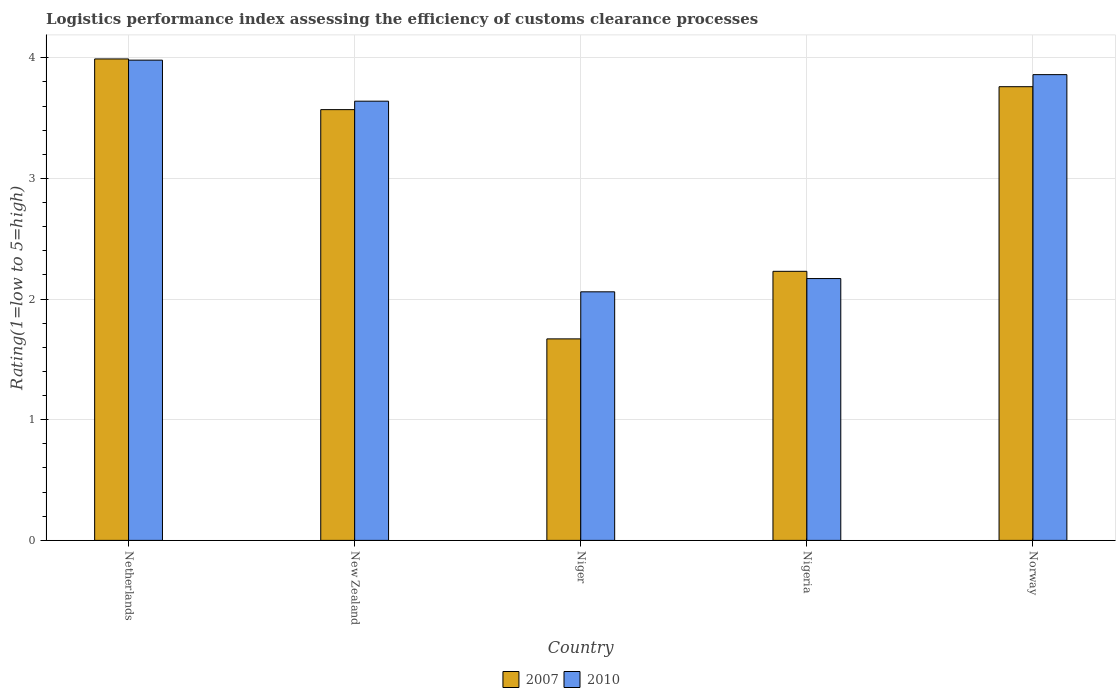How many different coloured bars are there?
Make the answer very short. 2. How many groups of bars are there?
Your answer should be compact. 5. Are the number of bars on each tick of the X-axis equal?
Your answer should be very brief. Yes. What is the label of the 5th group of bars from the left?
Your answer should be compact. Norway. In how many cases, is the number of bars for a given country not equal to the number of legend labels?
Ensure brevity in your answer.  0. What is the Logistic performance index in 2010 in Nigeria?
Your answer should be very brief. 2.17. Across all countries, what is the maximum Logistic performance index in 2010?
Ensure brevity in your answer.  3.98. Across all countries, what is the minimum Logistic performance index in 2010?
Ensure brevity in your answer.  2.06. In which country was the Logistic performance index in 2010 minimum?
Your answer should be very brief. Niger. What is the total Logistic performance index in 2010 in the graph?
Provide a succinct answer. 15.71. What is the difference between the Logistic performance index in 2007 in New Zealand and that in Niger?
Keep it short and to the point. 1.9. What is the difference between the Logistic performance index in 2007 in Niger and the Logistic performance index in 2010 in New Zealand?
Offer a terse response. -1.97. What is the average Logistic performance index in 2007 per country?
Make the answer very short. 3.04. What is the difference between the Logistic performance index of/in 2007 and Logistic performance index of/in 2010 in New Zealand?
Ensure brevity in your answer.  -0.07. In how many countries, is the Logistic performance index in 2007 greater than 3.8?
Your answer should be very brief. 1. What is the ratio of the Logistic performance index in 2010 in Netherlands to that in New Zealand?
Your response must be concise. 1.09. Is the Logistic performance index in 2010 in Netherlands less than that in Norway?
Offer a very short reply. No. Is the difference between the Logistic performance index in 2007 in New Zealand and Niger greater than the difference between the Logistic performance index in 2010 in New Zealand and Niger?
Your answer should be compact. Yes. What is the difference between the highest and the second highest Logistic performance index in 2010?
Ensure brevity in your answer.  0.22. What is the difference between the highest and the lowest Logistic performance index in 2007?
Your response must be concise. 2.32. Is the sum of the Logistic performance index in 2007 in Netherlands and Nigeria greater than the maximum Logistic performance index in 2010 across all countries?
Provide a succinct answer. Yes. Are all the bars in the graph horizontal?
Your answer should be very brief. No. Are the values on the major ticks of Y-axis written in scientific E-notation?
Your answer should be very brief. No. Does the graph contain any zero values?
Offer a terse response. No. How many legend labels are there?
Provide a short and direct response. 2. What is the title of the graph?
Your answer should be compact. Logistics performance index assessing the efficiency of customs clearance processes. What is the label or title of the Y-axis?
Your answer should be compact. Rating(1=low to 5=high). What is the Rating(1=low to 5=high) of 2007 in Netherlands?
Provide a short and direct response. 3.99. What is the Rating(1=low to 5=high) in 2010 in Netherlands?
Offer a very short reply. 3.98. What is the Rating(1=low to 5=high) of 2007 in New Zealand?
Offer a terse response. 3.57. What is the Rating(1=low to 5=high) of 2010 in New Zealand?
Your answer should be compact. 3.64. What is the Rating(1=low to 5=high) of 2007 in Niger?
Make the answer very short. 1.67. What is the Rating(1=low to 5=high) of 2010 in Niger?
Provide a short and direct response. 2.06. What is the Rating(1=low to 5=high) of 2007 in Nigeria?
Ensure brevity in your answer.  2.23. What is the Rating(1=low to 5=high) of 2010 in Nigeria?
Provide a short and direct response. 2.17. What is the Rating(1=low to 5=high) in 2007 in Norway?
Offer a terse response. 3.76. What is the Rating(1=low to 5=high) in 2010 in Norway?
Make the answer very short. 3.86. Across all countries, what is the maximum Rating(1=low to 5=high) of 2007?
Keep it short and to the point. 3.99. Across all countries, what is the maximum Rating(1=low to 5=high) of 2010?
Your answer should be compact. 3.98. Across all countries, what is the minimum Rating(1=low to 5=high) in 2007?
Your response must be concise. 1.67. Across all countries, what is the minimum Rating(1=low to 5=high) in 2010?
Offer a terse response. 2.06. What is the total Rating(1=low to 5=high) of 2007 in the graph?
Your answer should be compact. 15.22. What is the total Rating(1=low to 5=high) of 2010 in the graph?
Offer a terse response. 15.71. What is the difference between the Rating(1=low to 5=high) in 2007 in Netherlands and that in New Zealand?
Your answer should be very brief. 0.42. What is the difference between the Rating(1=low to 5=high) in 2010 in Netherlands and that in New Zealand?
Give a very brief answer. 0.34. What is the difference between the Rating(1=low to 5=high) in 2007 in Netherlands and that in Niger?
Your answer should be compact. 2.32. What is the difference between the Rating(1=low to 5=high) in 2010 in Netherlands and that in Niger?
Make the answer very short. 1.92. What is the difference between the Rating(1=low to 5=high) of 2007 in Netherlands and that in Nigeria?
Your response must be concise. 1.76. What is the difference between the Rating(1=low to 5=high) of 2010 in Netherlands and that in Nigeria?
Ensure brevity in your answer.  1.81. What is the difference between the Rating(1=low to 5=high) of 2007 in Netherlands and that in Norway?
Offer a terse response. 0.23. What is the difference between the Rating(1=low to 5=high) of 2010 in Netherlands and that in Norway?
Your answer should be compact. 0.12. What is the difference between the Rating(1=low to 5=high) of 2010 in New Zealand and that in Niger?
Give a very brief answer. 1.58. What is the difference between the Rating(1=low to 5=high) of 2007 in New Zealand and that in Nigeria?
Your answer should be compact. 1.34. What is the difference between the Rating(1=low to 5=high) of 2010 in New Zealand and that in Nigeria?
Make the answer very short. 1.47. What is the difference between the Rating(1=low to 5=high) in 2007 in New Zealand and that in Norway?
Provide a succinct answer. -0.19. What is the difference between the Rating(1=low to 5=high) in 2010 in New Zealand and that in Norway?
Your answer should be very brief. -0.22. What is the difference between the Rating(1=low to 5=high) in 2007 in Niger and that in Nigeria?
Ensure brevity in your answer.  -0.56. What is the difference between the Rating(1=low to 5=high) of 2010 in Niger and that in Nigeria?
Make the answer very short. -0.11. What is the difference between the Rating(1=low to 5=high) of 2007 in Niger and that in Norway?
Provide a short and direct response. -2.09. What is the difference between the Rating(1=low to 5=high) of 2007 in Nigeria and that in Norway?
Your answer should be compact. -1.53. What is the difference between the Rating(1=low to 5=high) in 2010 in Nigeria and that in Norway?
Provide a short and direct response. -1.69. What is the difference between the Rating(1=low to 5=high) of 2007 in Netherlands and the Rating(1=low to 5=high) of 2010 in New Zealand?
Give a very brief answer. 0.35. What is the difference between the Rating(1=low to 5=high) in 2007 in Netherlands and the Rating(1=low to 5=high) in 2010 in Niger?
Offer a terse response. 1.93. What is the difference between the Rating(1=low to 5=high) of 2007 in Netherlands and the Rating(1=low to 5=high) of 2010 in Nigeria?
Your answer should be very brief. 1.82. What is the difference between the Rating(1=low to 5=high) of 2007 in Netherlands and the Rating(1=low to 5=high) of 2010 in Norway?
Provide a short and direct response. 0.13. What is the difference between the Rating(1=low to 5=high) in 2007 in New Zealand and the Rating(1=low to 5=high) in 2010 in Niger?
Give a very brief answer. 1.51. What is the difference between the Rating(1=low to 5=high) in 2007 in New Zealand and the Rating(1=low to 5=high) in 2010 in Norway?
Ensure brevity in your answer.  -0.29. What is the difference between the Rating(1=low to 5=high) of 2007 in Niger and the Rating(1=low to 5=high) of 2010 in Nigeria?
Offer a very short reply. -0.5. What is the difference between the Rating(1=low to 5=high) in 2007 in Niger and the Rating(1=low to 5=high) in 2010 in Norway?
Your answer should be very brief. -2.19. What is the difference between the Rating(1=low to 5=high) in 2007 in Nigeria and the Rating(1=low to 5=high) in 2010 in Norway?
Make the answer very short. -1.63. What is the average Rating(1=low to 5=high) in 2007 per country?
Provide a short and direct response. 3.04. What is the average Rating(1=low to 5=high) of 2010 per country?
Make the answer very short. 3.14. What is the difference between the Rating(1=low to 5=high) in 2007 and Rating(1=low to 5=high) in 2010 in New Zealand?
Offer a terse response. -0.07. What is the difference between the Rating(1=low to 5=high) in 2007 and Rating(1=low to 5=high) in 2010 in Niger?
Ensure brevity in your answer.  -0.39. What is the difference between the Rating(1=low to 5=high) in 2007 and Rating(1=low to 5=high) in 2010 in Nigeria?
Your answer should be compact. 0.06. What is the ratio of the Rating(1=low to 5=high) in 2007 in Netherlands to that in New Zealand?
Your answer should be compact. 1.12. What is the ratio of the Rating(1=low to 5=high) of 2010 in Netherlands to that in New Zealand?
Ensure brevity in your answer.  1.09. What is the ratio of the Rating(1=low to 5=high) of 2007 in Netherlands to that in Niger?
Your answer should be very brief. 2.39. What is the ratio of the Rating(1=low to 5=high) in 2010 in Netherlands to that in Niger?
Keep it short and to the point. 1.93. What is the ratio of the Rating(1=low to 5=high) of 2007 in Netherlands to that in Nigeria?
Provide a succinct answer. 1.79. What is the ratio of the Rating(1=low to 5=high) in 2010 in Netherlands to that in Nigeria?
Give a very brief answer. 1.83. What is the ratio of the Rating(1=low to 5=high) in 2007 in Netherlands to that in Norway?
Your answer should be compact. 1.06. What is the ratio of the Rating(1=low to 5=high) of 2010 in Netherlands to that in Norway?
Provide a short and direct response. 1.03. What is the ratio of the Rating(1=low to 5=high) in 2007 in New Zealand to that in Niger?
Make the answer very short. 2.14. What is the ratio of the Rating(1=low to 5=high) in 2010 in New Zealand to that in Niger?
Provide a short and direct response. 1.77. What is the ratio of the Rating(1=low to 5=high) of 2007 in New Zealand to that in Nigeria?
Offer a very short reply. 1.6. What is the ratio of the Rating(1=low to 5=high) in 2010 in New Zealand to that in Nigeria?
Give a very brief answer. 1.68. What is the ratio of the Rating(1=low to 5=high) of 2007 in New Zealand to that in Norway?
Provide a succinct answer. 0.95. What is the ratio of the Rating(1=low to 5=high) in 2010 in New Zealand to that in Norway?
Offer a terse response. 0.94. What is the ratio of the Rating(1=low to 5=high) of 2007 in Niger to that in Nigeria?
Offer a terse response. 0.75. What is the ratio of the Rating(1=low to 5=high) in 2010 in Niger to that in Nigeria?
Provide a succinct answer. 0.95. What is the ratio of the Rating(1=low to 5=high) in 2007 in Niger to that in Norway?
Ensure brevity in your answer.  0.44. What is the ratio of the Rating(1=low to 5=high) of 2010 in Niger to that in Norway?
Ensure brevity in your answer.  0.53. What is the ratio of the Rating(1=low to 5=high) of 2007 in Nigeria to that in Norway?
Provide a succinct answer. 0.59. What is the ratio of the Rating(1=low to 5=high) in 2010 in Nigeria to that in Norway?
Ensure brevity in your answer.  0.56. What is the difference between the highest and the second highest Rating(1=low to 5=high) in 2007?
Make the answer very short. 0.23. What is the difference between the highest and the second highest Rating(1=low to 5=high) in 2010?
Your answer should be very brief. 0.12. What is the difference between the highest and the lowest Rating(1=low to 5=high) of 2007?
Give a very brief answer. 2.32. What is the difference between the highest and the lowest Rating(1=low to 5=high) of 2010?
Your response must be concise. 1.92. 